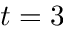<formula> <loc_0><loc_0><loc_500><loc_500>t = 3</formula> 